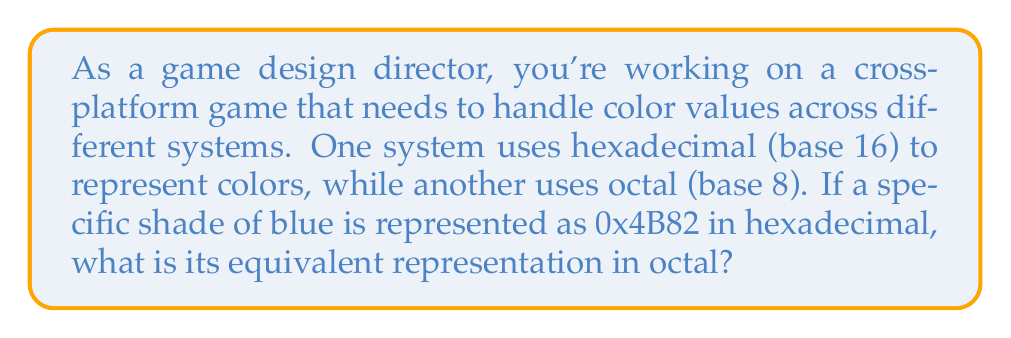What is the answer to this math problem? To convert the hexadecimal number 0x4B82 to octal, we'll follow these steps:

1. Convert hexadecimal to decimal:
   $0x4B82_{16} = 4 \times 16^3 + 11 \times 16^2 + 8 \times 16^1 + 2 \times 16^0$
   $= 4 \times 4096 + 11 \times 256 + 8 \times 16 + 2 \times 1$
   $= 16384 + 2816 + 128 + 2$
   $= 19330_{10}$

2. Convert decimal to octal:
   To convert to octal, we divide the decimal number by 8 repeatedly and read the remainders from bottom to top.

   $$\begin{array}{r}
   19330 \div 8 = 2416 \text{ remainder } 2 \\
   2416 \div 8 = 302 \text{ remainder } 0 \\
   302 \div 8 = 37 \text{ remainder } 6 \\
   37 \div 8 = 4 \text{ remainder } 5 \\
   4 \div 8 = 0 \text{ remainder } 4
   \end{array}$$

   Reading the remainders from bottom to top, we get: $45602_8$

Therefore, the hexadecimal value 0x4B82 is equivalent to 45602 in octal.
Answer: $45602_8$ 